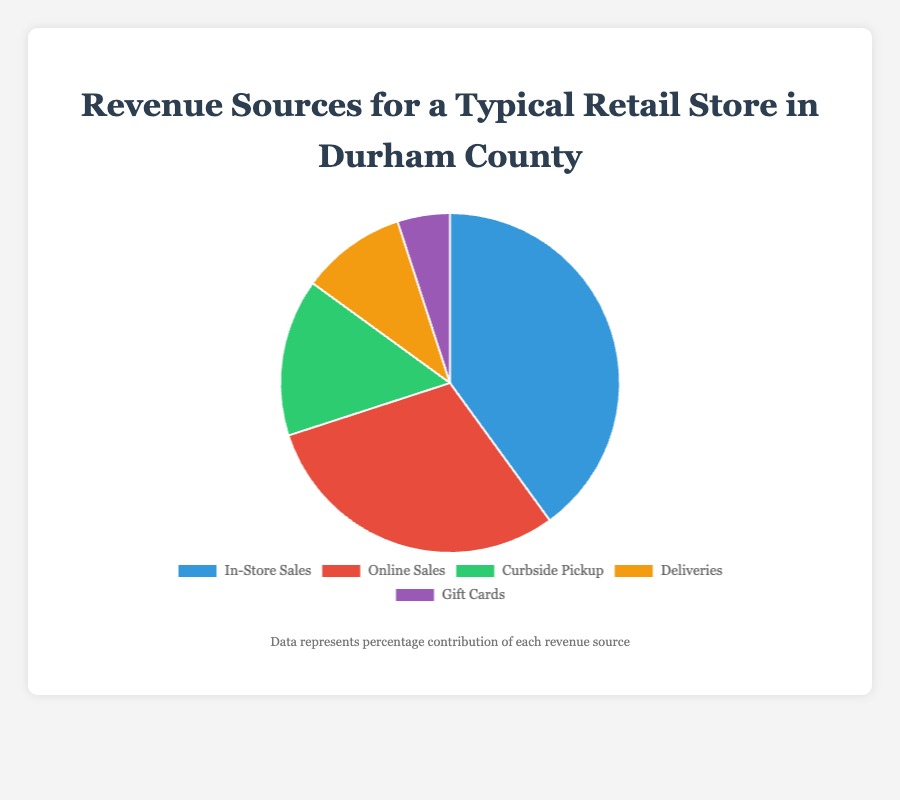What's the largest revenue source? The largest revenue source is the segment with the highest percentage in the chart. In this case, it is "In-Store Sales" with 40%.
Answer: In-Store Sales Which revenue source has the smallest share? The revenue source with the smallest share is the segment with the lowest percentage in the chart. In this case, it is "Gift Cards" with 5%.
Answer: Gift Cards What is the combined percentage of the two smallest revenue sources? To find the combined percentage of the smallest revenue sources, add their percentages together: 15% (Curbside Pickup) + 10% (Deliveries) = 25%.
Answer: 25% By how much does In-Store Sales exceed Online Sales? Subtract the percentage of Online Sales from In-Store Sales: 40% - 30% = 10%.
Answer: 10% What’s the visual representation of Online Sales in the pie chart? Online Sales is represented by a red segment in the pie chart.
Answer: Red segment What fraction of the total revenue comes from Curbside Pickup and Deliveries combined? Add the percentages of Curbside Pickup and Deliveries: 15% + 10% = 25%.
Answer: 25% Is the percentage of Online Sales greater than the combined percentage of Deliveries and Gift Cards? Compare Online Sales (30%) with the combined percentage of Deliveries and Gift Cards: 10% + 5% = 15%. Since 30% > 15%, Online Sales is greater.
Answer: Yes Rank the revenue sources from highest to lowest. List the revenue sources in order of their percentage: In-Store Sales (40%), Online Sales (30%), Curbside Pickup (15%), Deliveries (10%), Gift Cards (5%).
Answer: In-Store Sales, Online Sales, Curbside Pickup, Deliveries, Gift Cards If the store wants to increase its Curbside Pickup revenue to be equal to Online Sales, what percentage increase is needed? Determine the difference between Online Sales and Curbside Pickup: 30% - 15% = 15%. Therefore, the store needs a 15% increase.
Answer: 15% How much more significant is the largest revenue source compared to the smallest? Subtract the percentage of the smallest revenue source (Gift Cards) from the largest (In-Store Sales): 40% - 5% = 35%.
Answer: 35% 